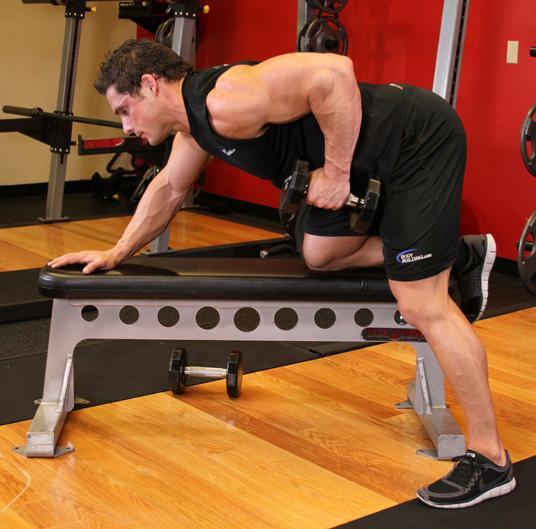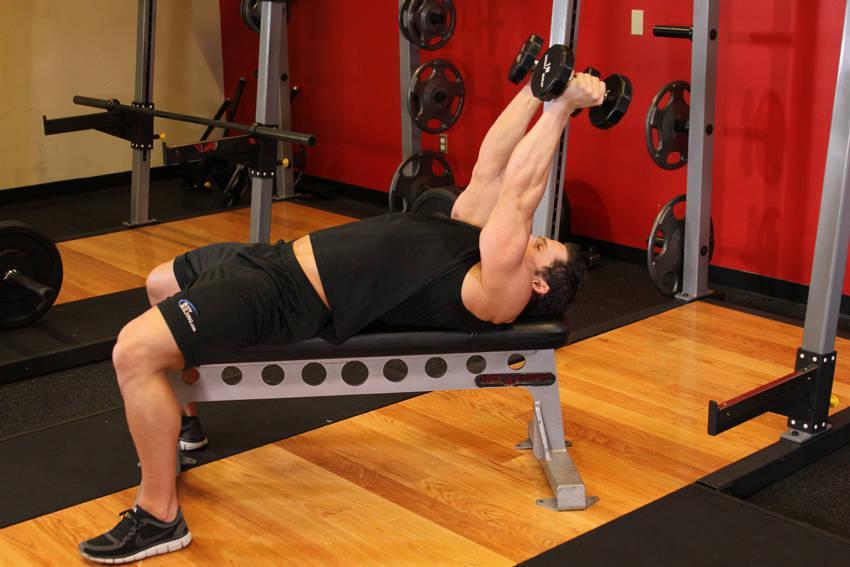The first image is the image on the left, the second image is the image on the right. Examine the images to the left and right. Is the description "There is a man dressed in black shorts and a red shirt in one of the images" accurate? Answer yes or no. No. 